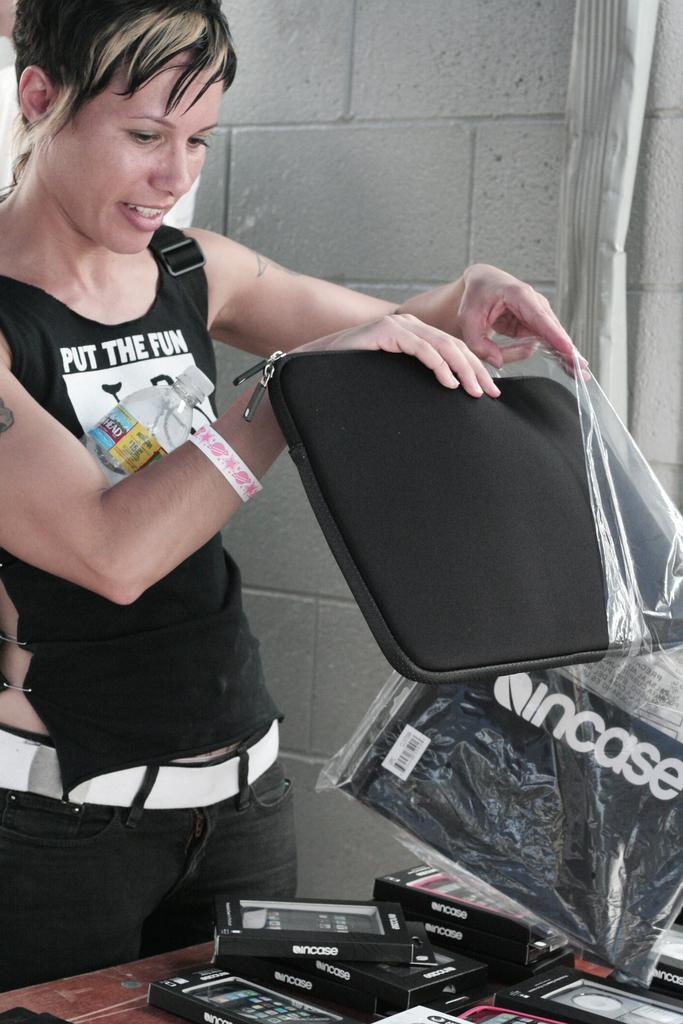Who is the main subject in the image? There is a girl in the image. Where is the girl positioned in the image? The girl is standing on the left side of the image. What is the girl holding in her hands? The girl is holding a bag in her hands. What is in front of the girl in the image? There is a table in front of the girl. What is on the table in the image? There are boxes on the table. What type of string is the girl using to express regret in the image? There is no string or expression of regret present in the image. 